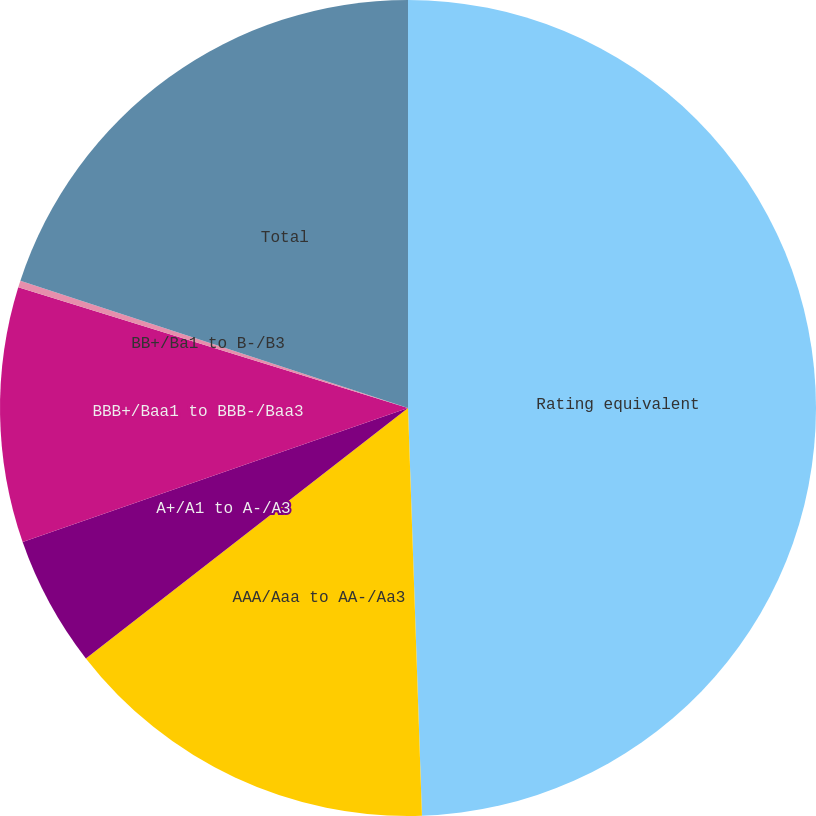Convert chart to OTSL. <chart><loc_0><loc_0><loc_500><loc_500><pie_chart><fcel>Rating equivalent<fcel>AAA/Aaa to AA-/Aa3<fcel>A+/A1 to A-/A3<fcel>BBB+/Baa1 to BBB-/Baa3<fcel>BB+/Ba1 to B-/B3<fcel>Total<nl><fcel>49.46%<fcel>15.03%<fcel>5.19%<fcel>10.11%<fcel>0.27%<fcel>19.95%<nl></chart> 